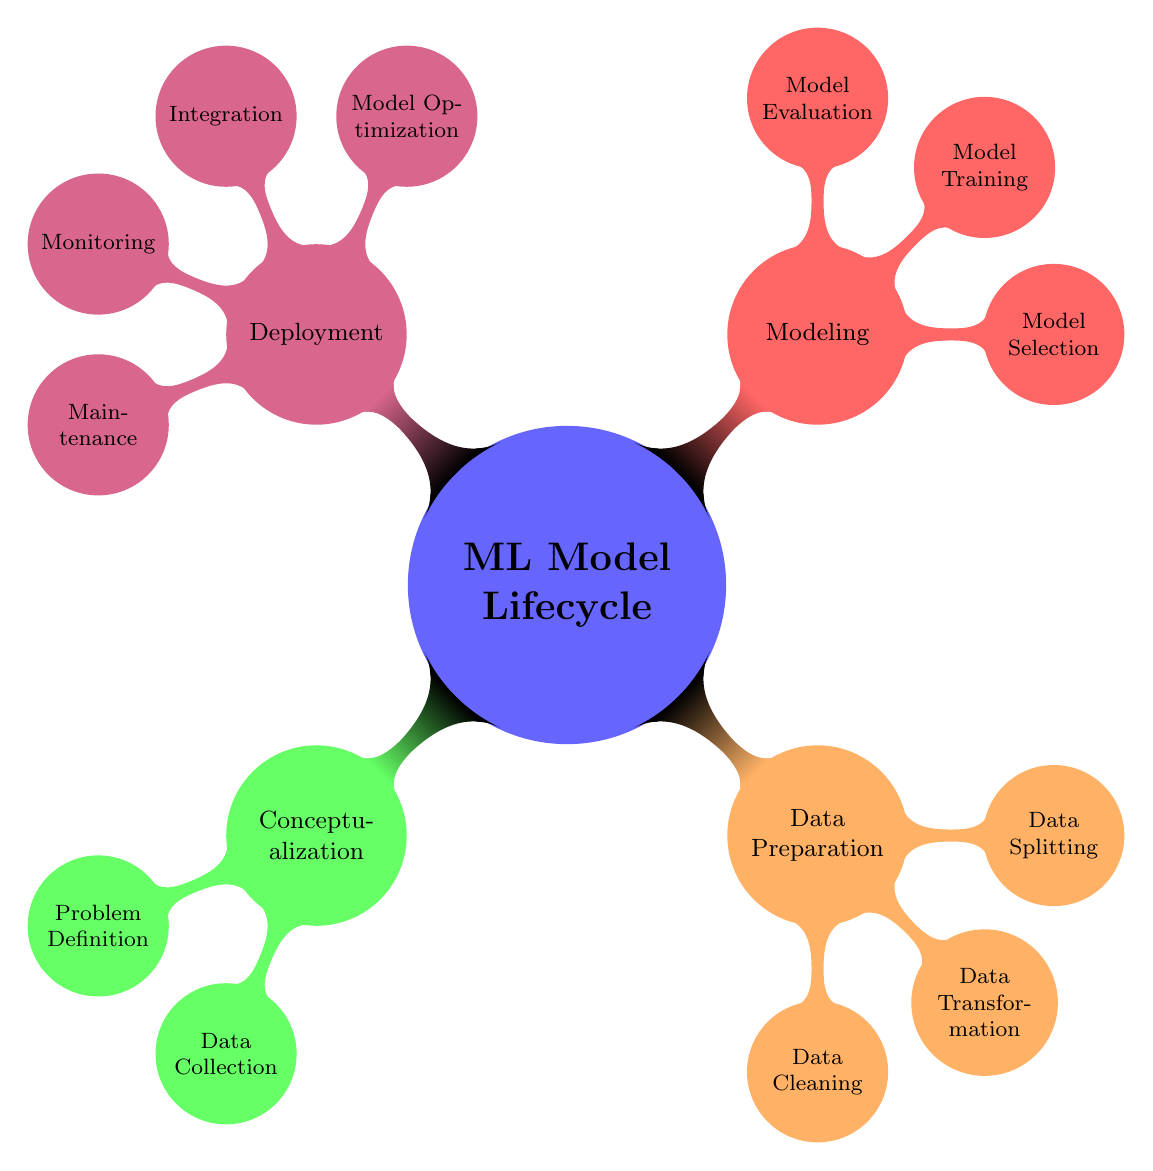What is the main subject represented in the mind map? The main subject of the mind map is the "ML Model Lifecycle", which is indicated at the center of the diagram.
Answer: ML Model Lifecycle How many major phases are identified in the model lifecycle? The diagram outlines four major phases: Conceptualization, Data Preparation, Modeling, and Deployment. I counted these nodes that represent each phase.
Answer: Four Which phase includes data cleaning? The "Data Preparation" phase includes "Data Cleaning" as one of its components, as indicated by its placement in the hierarchy under this phase.
Answer: Data Preparation What are the two child nodes under the "Modeling" phase? The "Modeling" phase has three child nodes: Model Selection, Model Training, and Model Evaluation. In this case, we can specify any two of these nodes.
Answer: Model Selection, Model Training What is the relationship between "Data Collection" and "Conceptualization"? "Data Collection" is a child node of "Conceptualization," showing that it is a subcategory within this main phase of the ML lifecycle diagram.
Answer: Child node How many components are in the "Deployment" phase? The "Deployment" phase consists of four components: Model Optimization, Integration, Monitoring, and Maintenance, as shown by the four child nodes branching from the Deployment node.
Answer: Four Which components are included in the "Model Evaluation" section? The "Model Evaluation" section consists of Performance Metrics, which further breaks down into Accuracy, Precision, and Recall, indicating the key evaluation measures used in this process.
Answer: Performance Metrics, Accuracy, Precision, Recall What comes after "Data Transformation" in the data preparation phase? After "Data Transformation," the next component in the Data Preparation phase is "Data Splitting," which follows in the hierarchy of nodes within this phase.
Answer: Data Splitting What specific activity is associated with "Hyperparameter Tuning"? "Hyperparameter Tuning" is associated with "Model Training," as indicated by its position as a child node under the larger modeling phase.
Answer: Model Training 